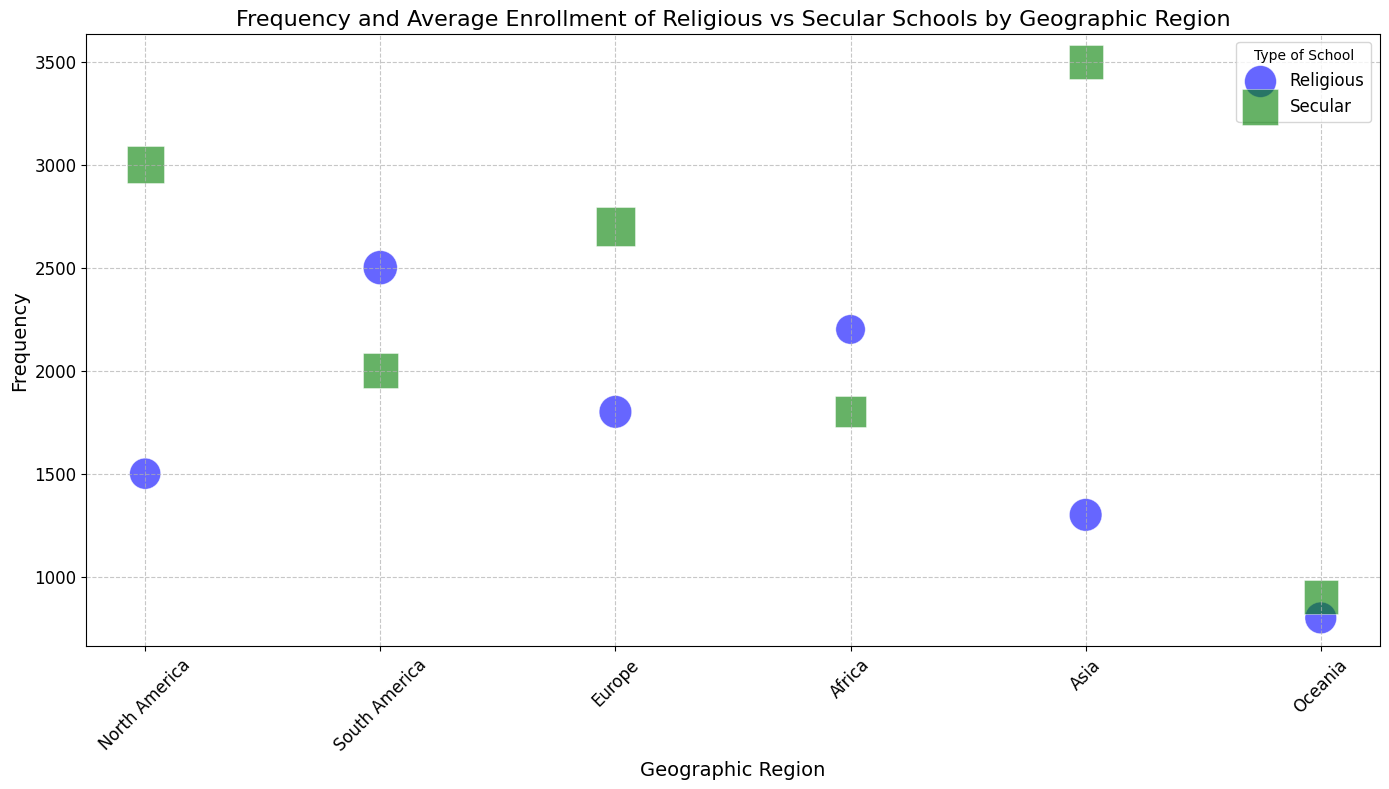How many more secular schools are there than religious schools in Asia? In Asia, there are 3,500 secular schools and 1,300 religious schools. Subtract the number of religious schools from the number of secular schools: 3,500 - 1,300 = 2,200
Answer: 2,200 Which geographic region has the highest frequency of religious schools? Looking at the bubble chart, the region with the highest frequency of religious schools is South America with 2,500 religious schools
Answer: South America What is the average enrollment for secular schools in Europe? From the bubble chart, the average enrollment for secular schools in Europe is represented by the size of the green square in Europe, which is 800
Answer: 800 Are there more religious schools or secular schools in North America? The bubble chart shows that North America has 1,500 religious schools (blue circles) and 3,000 secular schools (green squares). Since 3,000 is greater than 1,500, there are more secular schools in North America
Answer: Secular schools In which geographic region is the difference in frequency between religious and secular schools the smallest? By examining the bubble sizes and counts, Oceania has the smallest difference in frequency. Secular schools: 900, Religious schools: 800. The difference is 900 - 800 = 100
Answer: Oceania Compare the average enrollment for religious schools in North America and South America. Which one is larger? The average enrollment for religious schools in North America is 500 and in South America is 600. By comparison, 600 is greater than 500, so South America has a larger average enrollment for religious schools
Answer: South America How is the frequency of religious and secular schools visually represented in the plot? The frequency of religious schools is represented by blue circles, and the frequency of secular schools is represented by green squares. The size of the bubbles is proportional to the average enrollment
Answer: Blue circles for religious, green squares for secular Which region has the highest total number of schools (both religious and secular)? By adding the frequencies of religious and secular schools in each region:
- North America: 1,500 + 3,000 = 4,500
- South America: 2,500 + 2,000 = 4,500
- Europe: 1,800 + 2,700 = 4,500
- Africa: 2,200 + 1,800 = 4,000
- Asia: 1,300 + 3,500 = 4,800
- Oceania: 800 + 900 = 1,700
Asia has the highest total number of schools, with a total of 4,800
Answer: Asia What can be inferred about the average enrollment size of schools in Oceania compared to other regions? Observing the bubble sizes, the average enrollment sizes in Oceania are relatively smaller than in many other regions. This can be inferred from the smaller sizes of both blue circles and green squares in Oceania
Answer: Smaller sizes in Oceania In Africa, are the frequencies of religious and secular schools nearly equal, and what are their average enrollments? The bubble chart shows that Africa has 2,200 religious schools and 1,800 secular schools. Their average enrollments are 450 for religious and 500 for secular
Answer: Nearly equal frequencies, 450 for religious, 500 for secular 